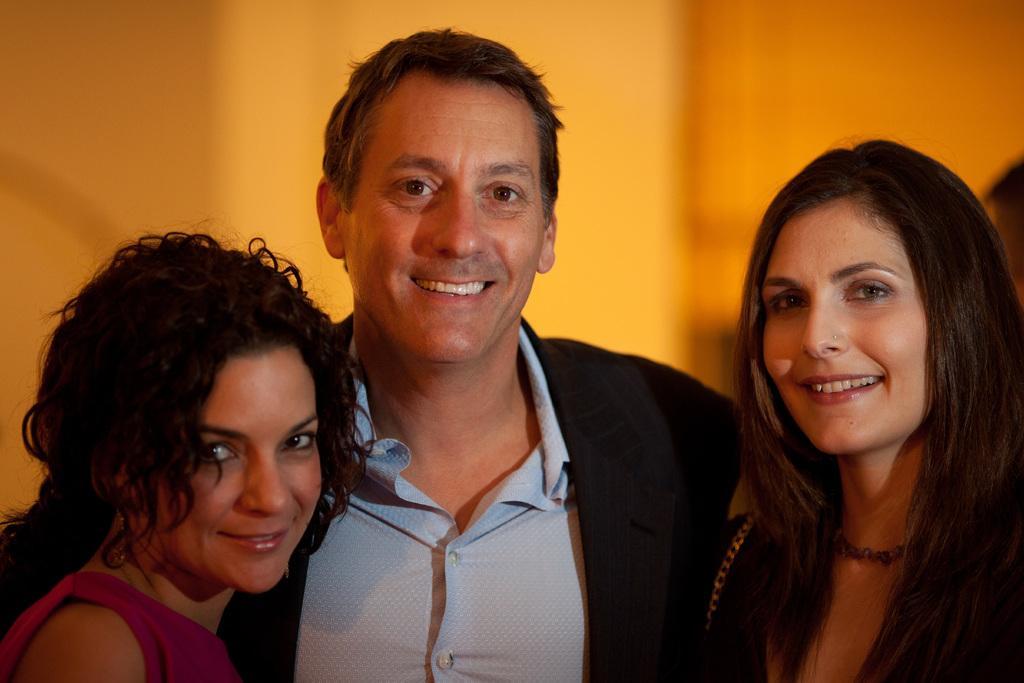Could you give a brief overview of what you see in this image? This picture describe about the man wearing a blue shirt and black coat standing in the middle of the image, smiling and giving a pose into the camera. On the right and left side we can see your two woman standing beside him, smiling and giving a pose into the camera. In the background we can see yellow color wall. 